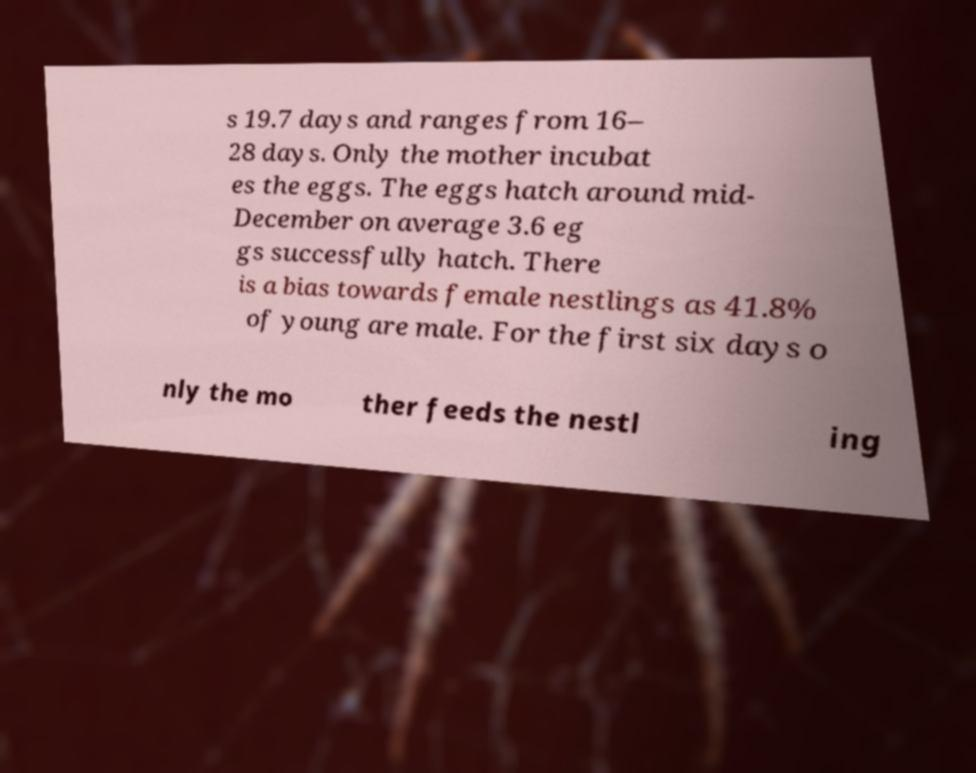Can you read and provide the text displayed in the image?This photo seems to have some interesting text. Can you extract and type it out for me? s 19.7 days and ranges from 16– 28 days. Only the mother incubat es the eggs. The eggs hatch around mid- December on average 3.6 eg gs successfully hatch. There is a bias towards female nestlings as 41.8% of young are male. For the first six days o nly the mo ther feeds the nestl ing 